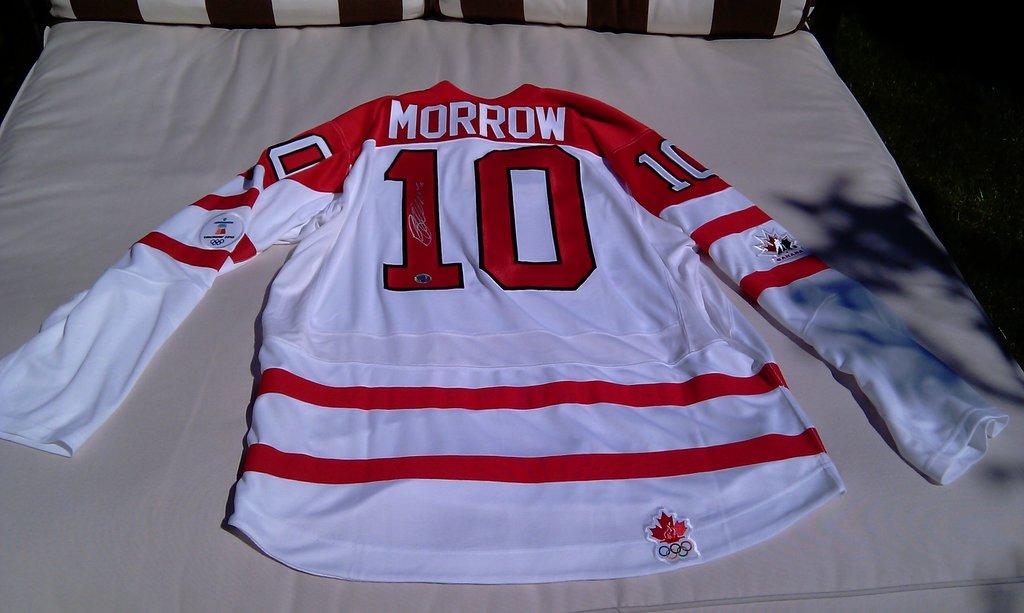What is the number on the shirt?
Make the answer very short. 10. What is the name of the person this jersey belongs to?
Make the answer very short. Morrow. 